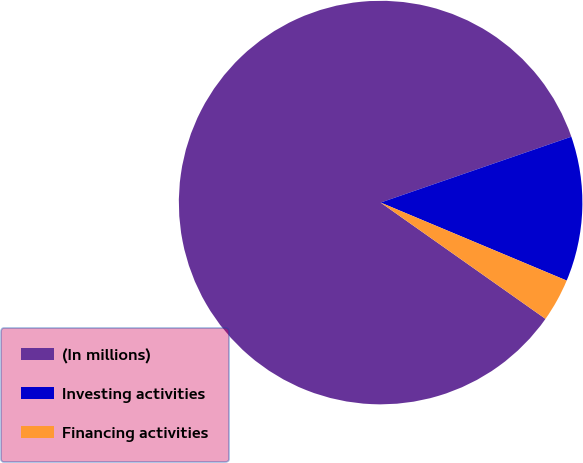Convert chart to OTSL. <chart><loc_0><loc_0><loc_500><loc_500><pie_chart><fcel>(In millions)<fcel>Investing activities<fcel>Financing activities<nl><fcel>84.93%<fcel>11.61%<fcel>3.46%<nl></chart> 